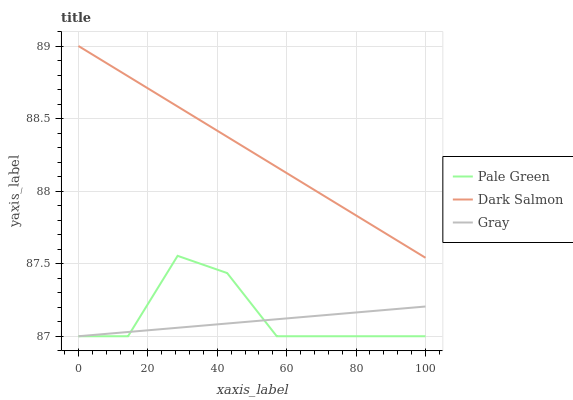Does Gray have the minimum area under the curve?
Answer yes or no. Yes. Does Dark Salmon have the maximum area under the curve?
Answer yes or no. Yes. Does Pale Green have the minimum area under the curve?
Answer yes or no. No. Does Pale Green have the maximum area under the curve?
Answer yes or no. No. Is Gray the smoothest?
Answer yes or no. Yes. Is Pale Green the roughest?
Answer yes or no. Yes. Is Dark Salmon the smoothest?
Answer yes or no. No. Is Dark Salmon the roughest?
Answer yes or no. No. Does Gray have the lowest value?
Answer yes or no. Yes. Does Dark Salmon have the lowest value?
Answer yes or no. No. Does Dark Salmon have the highest value?
Answer yes or no. Yes. Does Pale Green have the highest value?
Answer yes or no. No. Is Gray less than Dark Salmon?
Answer yes or no. Yes. Is Dark Salmon greater than Pale Green?
Answer yes or no. Yes. Does Pale Green intersect Gray?
Answer yes or no. Yes. Is Pale Green less than Gray?
Answer yes or no. No. Is Pale Green greater than Gray?
Answer yes or no. No. Does Gray intersect Dark Salmon?
Answer yes or no. No. 